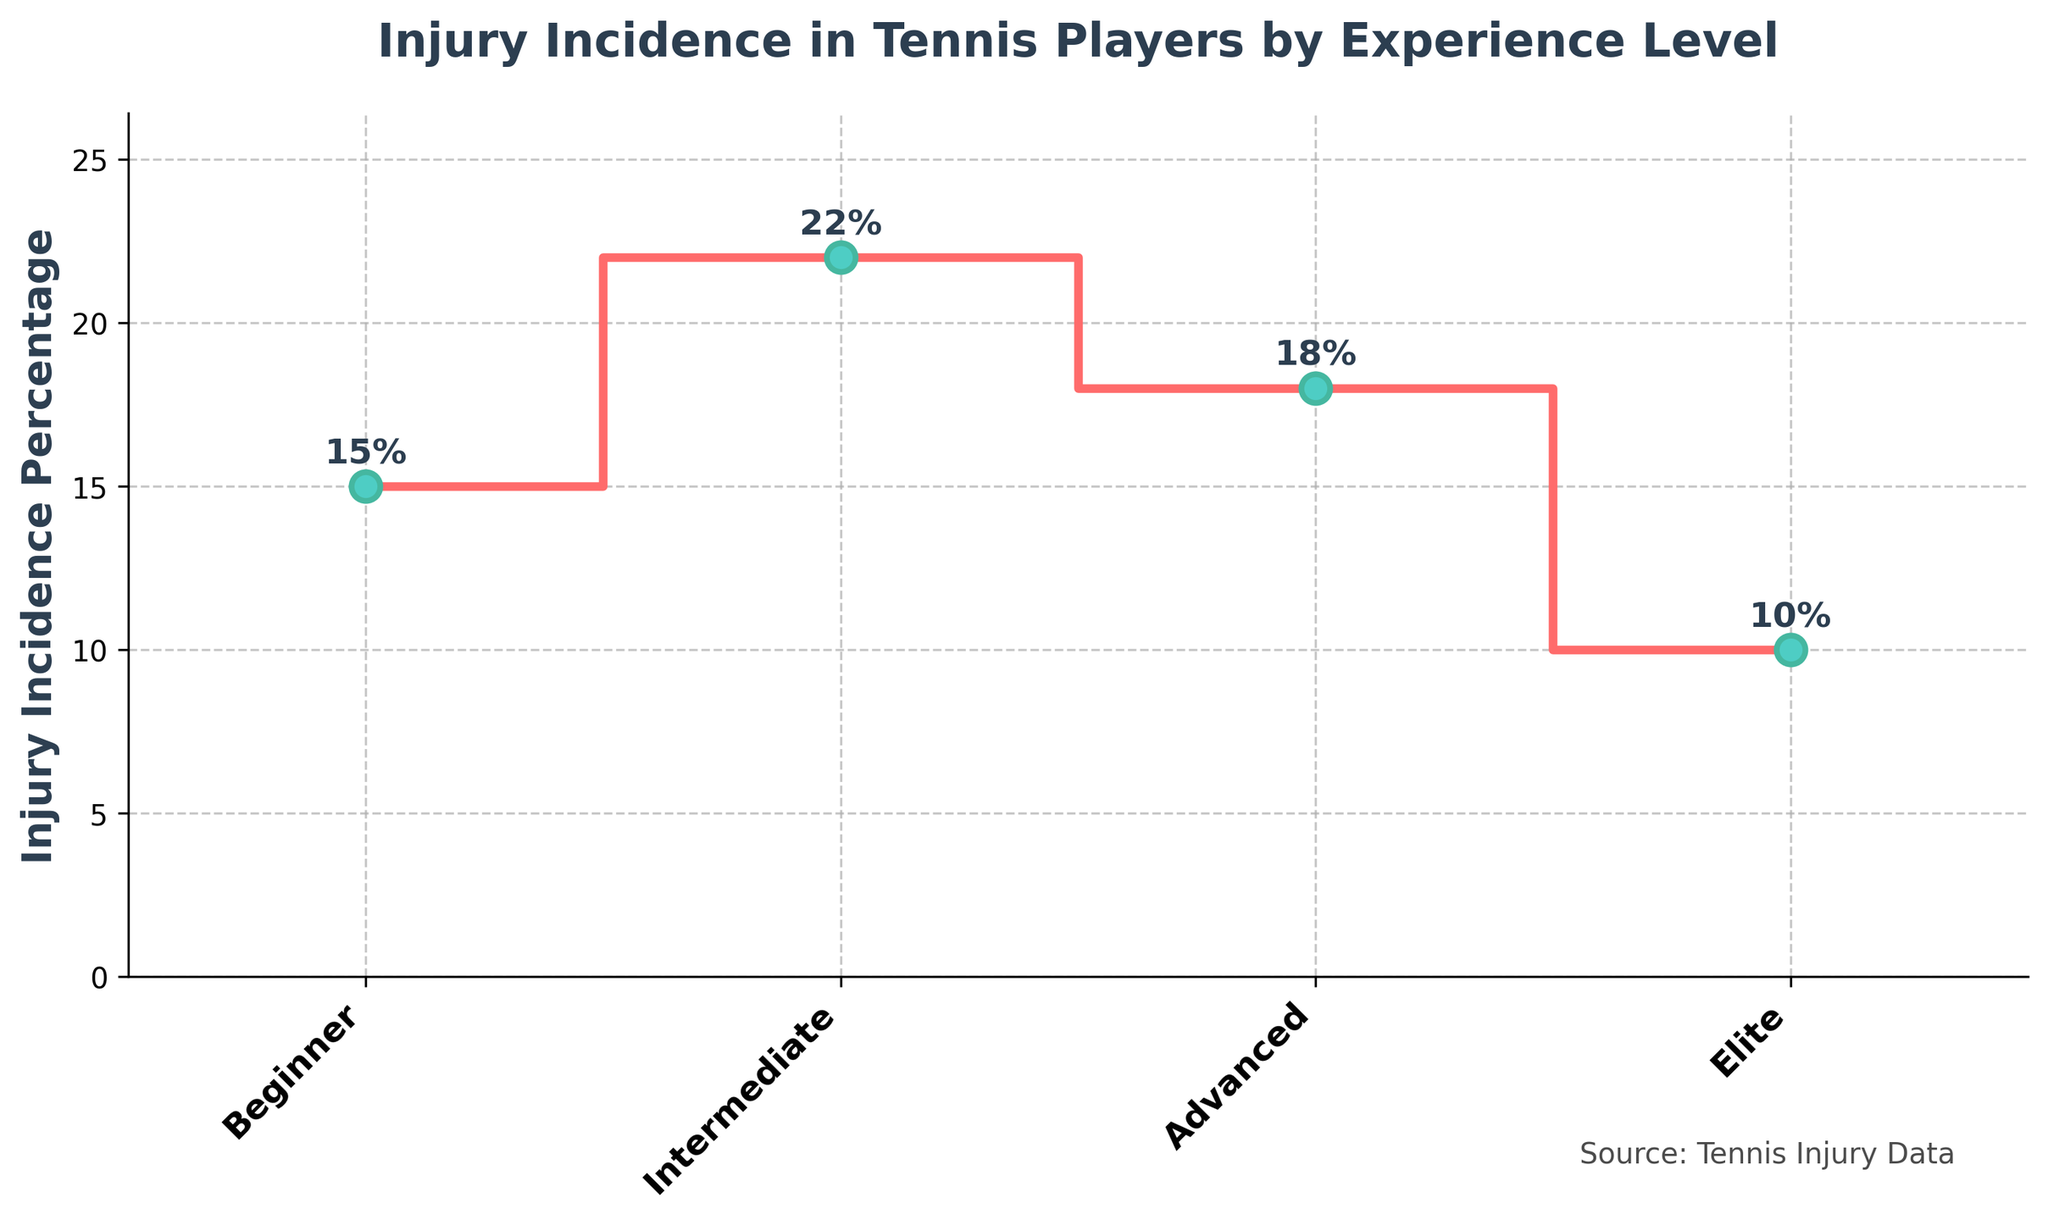What's the title of the plot? The title is typically displayed at the top of the plot in a larger, bold font. The title in this plot reads 'Injury Incidence in Tennis Players by Experience Level'.
Answer: Injury Incidence in Tennis Players by Experience Level What experience level has the highest injury incidence percentage? To determine this, look for the highest value in the stair plot. The highest point corresponds to 'Intermediate' with an injury incidence of 22%.
Answer: Intermediate How many experience levels are represented in the plot? Count the distinct categories on the x-axis. Here, 'Beginner', 'Intermediate', 'Advanced', 'Elite' are listed.
Answer: 4 What is the injury incidence percentage for elite players? Identify the point corresponding to 'Elite' on the x-axis and read its value on the y-axis, which is labeled as 10%.
Answer: 10% Which group has a lower injury incidence percentage: Beginners or Advanced players? Compare the y-axis values of 'Beginner' (15%) and 'Advanced' (18%). 'Beginner' group has a lower percentage.
Answer: Beginners What is the difference in injury incidence percentage between Intermediate and Elite players? Subtract the injury incidence percentage of Elite players from Intermediate players: 22% (Intermediate) - 10% (Elite) = 12%.
Answer: 12% Is there a noticeable trend in injury incidence percentages as experience level increases? Observe the plot progression from 'Beginner' to 'Elite'. There's a rise from Beginner to Intermediate, then a fall towards Elite. Thus, the trend isn't monotonically increasing or decreasing.
Answer: No consistent trend What is the average injury incidence percentage across all experience levels? Sum the percentages: 15 + 22 + 18 + 10 = 65. Divide by the number of groups (4): 65/4 = 16.25%.
Answer: 16.25% Which experience level has the closest injury incidence percentage to the average value? The average is 16.25%. Compare each injury incidence value to the average and find the closest one. 'Advanced' with 18% is the closest.
Answer: Advanced What source is mentioned for the data in the plot? A text note at the bottom of the plot indicates the source. The source mentioned is 'Tennis Injury Data'.
Answer: Tennis Injury Data 